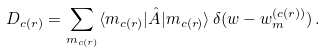Convert formula to latex. <formula><loc_0><loc_0><loc_500><loc_500>D _ { c ( r ) } = \sum _ { m _ { c ( r ) } } \langle m _ { c ( r ) } | \hat { A } | m _ { c ( r ) } \rangle \, \delta ( w - w _ { m } ^ { ( c ( r ) ) } ) \, .</formula> 